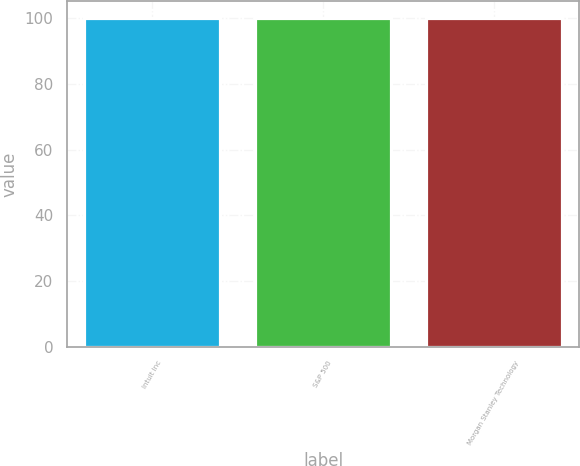<chart> <loc_0><loc_0><loc_500><loc_500><bar_chart><fcel>Intuit Inc<fcel>S&P 500<fcel>Morgan Stanley Technology<nl><fcel>100<fcel>100.1<fcel>100.2<nl></chart> 